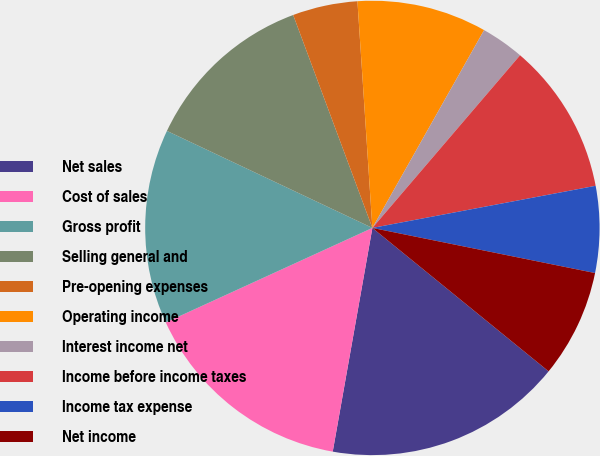<chart> <loc_0><loc_0><loc_500><loc_500><pie_chart><fcel>Net sales<fcel>Cost of sales<fcel>Gross profit<fcel>Selling general and<fcel>Pre-opening expenses<fcel>Operating income<fcel>Interest income net<fcel>Income before income taxes<fcel>Income tax expense<fcel>Net income<nl><fcel>16.92%<fcel>15.38%<fcel>13.85%<fcel>12.31%<fcel>4.62%<fcel>9.23%<fcel>3.08%<fcel>10.77%<fcel>6.15%<fcel>7.69%<nl></chart> 